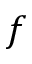Convert formula to latex. <formula><loc_0><loc_0><loc_500><loc_500>f</formula> 